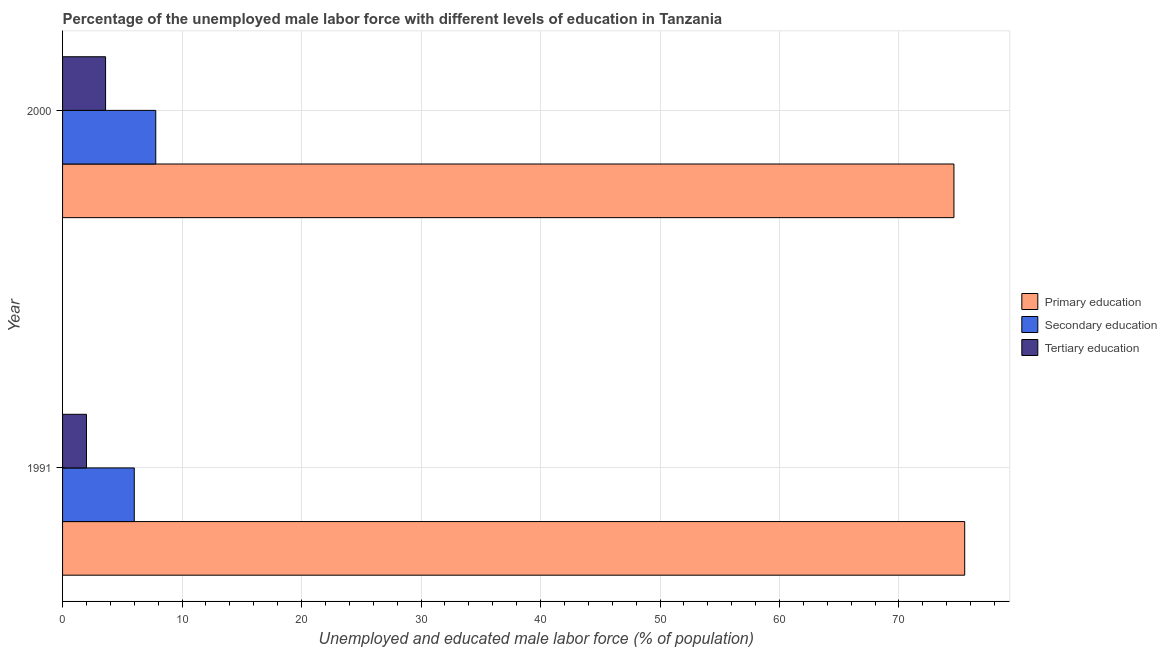How many groups of bars are there?
Keep it short and to the point. 2. How many bars are there on the 2nd tick from the top?
Keep it short and to the point. 3. How many bars are there on the 2nd tick from the bottom?
Keep it short and to the point. 3. What is the label of the 2nd group of bars from the top?
Keep it short and to the point. 1991. What is the percentage of male labor force who received secondary education in 1991?
Provide a succinct answer. 6. Across all years, what is the maximum percentage of male labor force who received secondary education?
Provide a short and direct response. 7.8. Across all years, what is the minimum percentage of male labor force who received primary education?
Your response must be concise. 74.6. In which year was the percentage of male labor force who received tertiary education maximum?
Your response must be concise. 2000. In which year was the percentage of male labor force who received primary education minimum?
Provide a short and direct response. 2000. What is the total percentage of male labor force who received primary education in the graph?
Provide a short and direct response. 150.1. What is the difference between the percentage of male labor force who received secondary education in 1991 and that in 2000?
Provide a short and direct response. -1.8. What is the difference between the percentage of male labor force who received primary education in 1991 and the percentage of male labor force who received secondary education in 2000?
Offer a very short reply. 67.7. What is the average percentage of male labor force who received tertiary education per year?
Ensure brevity in your answer.  2.8. In the year 1991, what is the difference between the percentage of male labor force who received primary education and percentage of male labor force who received secondary education?
Provide a succinct answer. 69.5. What is the ratio of the percentage of male labor force who received secondary education in 1991 to that in 2000?
Offer a very short reply. 0.77. Is the difference between the percentage of male labor force who received tertiary education in 1991 and 2000 greater than the difference between the percentage of male labor force who received primary education in 1991 and 2000?
Your answer should be compact. No. In how many years, is the percentage of male labor force who received primary education greater than the average percentage of male labor force who received primary education taken over all years?
Ensure brevity in your answer.  1. What does the 1st bar from the top in 1991 represents?
Your answer should be compact. Tertiary education. What does the 3rd bar from the bottom in 2000 represents?
Provide a succinct answer. Tertiary education. Is it the case that in every year, the sum of the percentage of male labor force who received primary education and percentage of male labor force who received secondary education is greater than the percentage of male labor force who received tertiary education?
Offer a terse response. Yes. How many bars are there?
Make the answer very short. 6. How many years are there in the graph?
Your answer should be compact. 2. What is the difference between two consecutive major ticks on the X-axis?
Offer a terse response. 10. Where does the legend appear in the graph?
Ensure brevity in your answer.  Center right. How are the legend labels stacked?
Keep it short and to the point. Vertical. What is the title of the graph?
Ensure brevity in your answer.  Percentage of the unemployed male labor force with different levels of education in Tanzania. What is the label or title of the X-axis?
Your response must be concise. Unemployed and educated male labor force (% of population). What is the Unemployed and educated male labor force (% of population) in Primary education in 1991?
Offer a very short reply. 75.5. What is the Unemployed and educated male labor force (% of population) in Secondary education in 1991?
Keep it short and to the point. 6. What is the Unemployed and educated male labor force (% of population) of Primary education in 2000?
Make the answer very short. 74.6. What is the Unemployed and educated male labor force (% of population) in Secondary education in 2000?
Make the answer very short. 7.8. What is the Unemployed and educated male labor force (% of population) of Tertiary education in 2000?
Provide a short and direct response. 3.6. Across all years, what is the maximum Unemployed and educated male labor force (% of population) in Primary education?
Offer a terse response. 75.5. Across all years, what is the maximum Unemployed and educated male labor force (% of population) of Secondary education?
Provide a succinct answer. 7.8. Across all years, what is the maximum Unemployed and educated male labor force (% of population) of Tertiary education?
Provide a short and direct response. 3.6. Across all years, what is the minimum Unemployed and educated male labor force (% of population) in Primary education?
Ensure brevity in your answer.  74.6. Across all years, what is the minimum Unemployed and educated male labor force (% of population) in Secondary education?
Your answer should be compact. 6. Across all years, what is the minimum Unemployed and educated male labor force (% of population) in Tertiary education?
Your answer should be compact. 2. What is the total Unemployed and educated male labor force (% of population) in Primary education in the graph?
Offer a very short reply. 150.1. What is the difference between the Unemployed and educated male labor force (% of population) in Primary education in 1991 and the Unemployed and educated male labor force (% of population) in Secondary education in 2000?
Your response must be concise. 67.7. What is the difference between the Unemployed and educated male labor force (% of population) of Primary education in 1991 and the Unemployed and educated male labor force (% of population) of Tertiary education in 2000?
Keep it short and to the point. 71.9. What is the average Unemployed and educated male labor force (% of population) of Primary education per year?
Keep it short and to the point. 75.05. What is the average Unemployed and educated male labor force (% of population) in Secondary education per year?
Keep it short and to the point. 6.9. In the year 1991, what is the difference between the Unemployed and educated male labor force (% of population) in Primary education and Unemployed and educated male labor force (% of population) in Secondary education?
Provide a succinct answer. 69.5. In the year 1991, what is the difference between the Unemployed and educated male labor force (% of population) of Primary education and Unemployed and educated male labor force (% of population) of Tertiary education?
Your response must be concise. 73.5. In the year 2000, what is the difference between the Unemployed and educated male labor force (% of population) in Primary education and Unemployed and educated male labor force (% of population) in Secondary education?
Keep it short and to the point. 66.8. In the year 2000, what is the difference between the Unemployed and educated male labor force (% of population) in Secondary education and Unemployed and educated male labor force (% of population) in Tertiary education?
Offer a terse response. 4.2. What is the ratio of the Unemployed and educated male labor force (% of population) in Primary education in 1991 to that in 2000?
Your response must be concise. 1.01. What is the ratio of the Unemployed and educated male labor force (% of population) of Secondary education in 1991 to that in 2000?
Your response must be concise. 0.77. What is the ratio of the Unemployed and educated male labor force (% of population) in Tertiary education in 1991 to that in 2000?
Offer a very short reply. 0.56. What is the difference between the highest and the second highest Unemployed and educated male labor force (% of population) in Tertiary education?
Keep it short and to the point. 1.6. What is the difference between the highest and the lowest Unemployed and educated male labor force (% of population) of Primary education?
Offer a very short reply. 0.9. What is the difference between the highest and the lowest Unemployed and educated male labor force (% of population) of Tertiary education?
Make the answer very short. 1.6. 